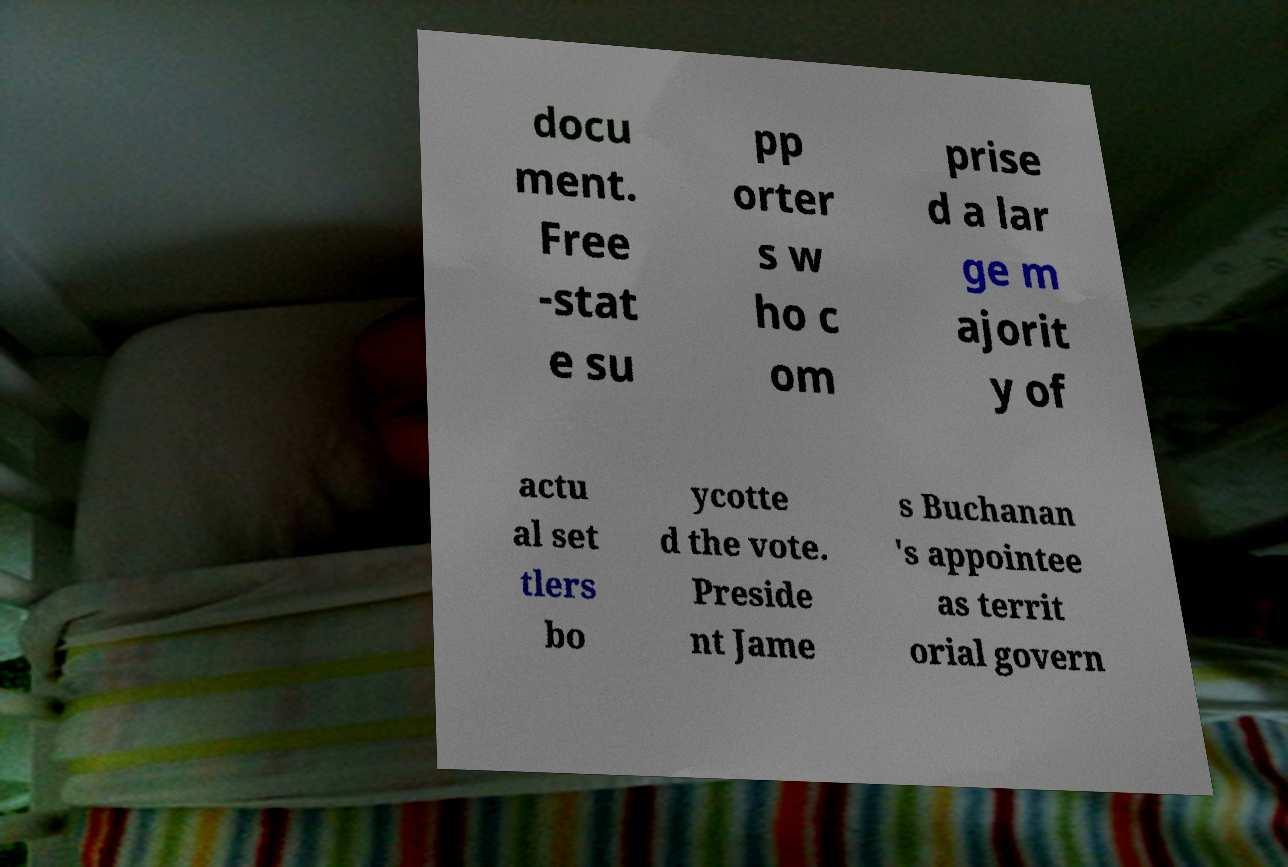Please identify and transcribe the text found in this image. docu ment. Free -stat e su pp orter s w ho c om prise d a lar ge m ajorit y of actu al set tlers bo ycotte d the vote. Preside nt Jame s Buchanan 's appointee as territ orial govern 